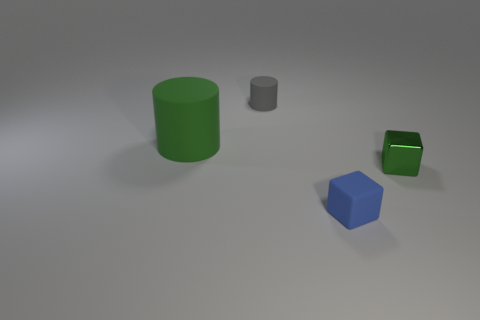Is there any other thing that has the same size as the green rubber thing?
Provide a short and direct response. No. What is the material of the green thing right of the cylinder that is behind the cylinder that is in front of the tiny matte cylinder?
Provide a succinct answer. Metal. There is a small gray rubber object; is its shape the same as the small rubber object in front of the small cylinder?
Offer a terse response. No. What number of other tiny rubber objects have the same shape as the gray object?
Provide a short and direct response. 0. The gray rubber thing has what shape?
Offer a terse response. Cylinder. There is a green thing on the right side of the matte thing that is behind the green matte object; what is its size?
Offer a terse response. Small. How many objects are big green matte things or small matte cylinders?
Keep it short and to the point. 2. Do the tiny gray thing and the big thing have the same shape?
Your answer should be compact. Yes. Is there a tiny green thing that has the same material as the small gray thing?
Provide a succinct answer. No. Are there any small blue blocks that are behind the cylinder that is on the left side of the small gray rubber object?
Give a very brief answer. No. 